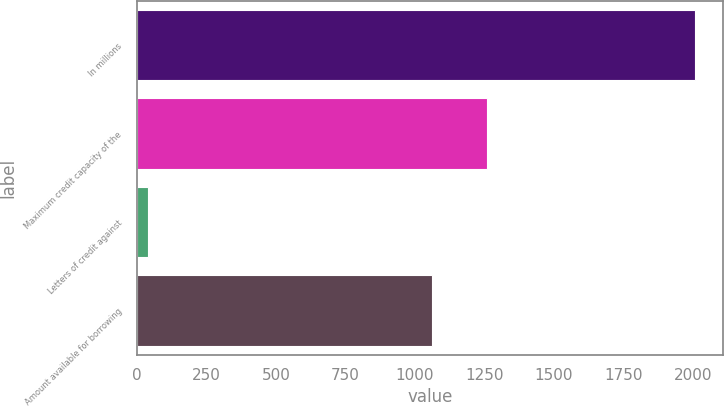<chart> <loc_0><loc_0><loc_500><loc_500><bar_chart><fcel>In millions<fcel>Maximum credit capacity of the<fcel>Letters of credit against<fcel>Amount available for borrowing<nl><fcel>2008<fcel>1257.9<fcel>39<fcel>1061<nl></chart> 